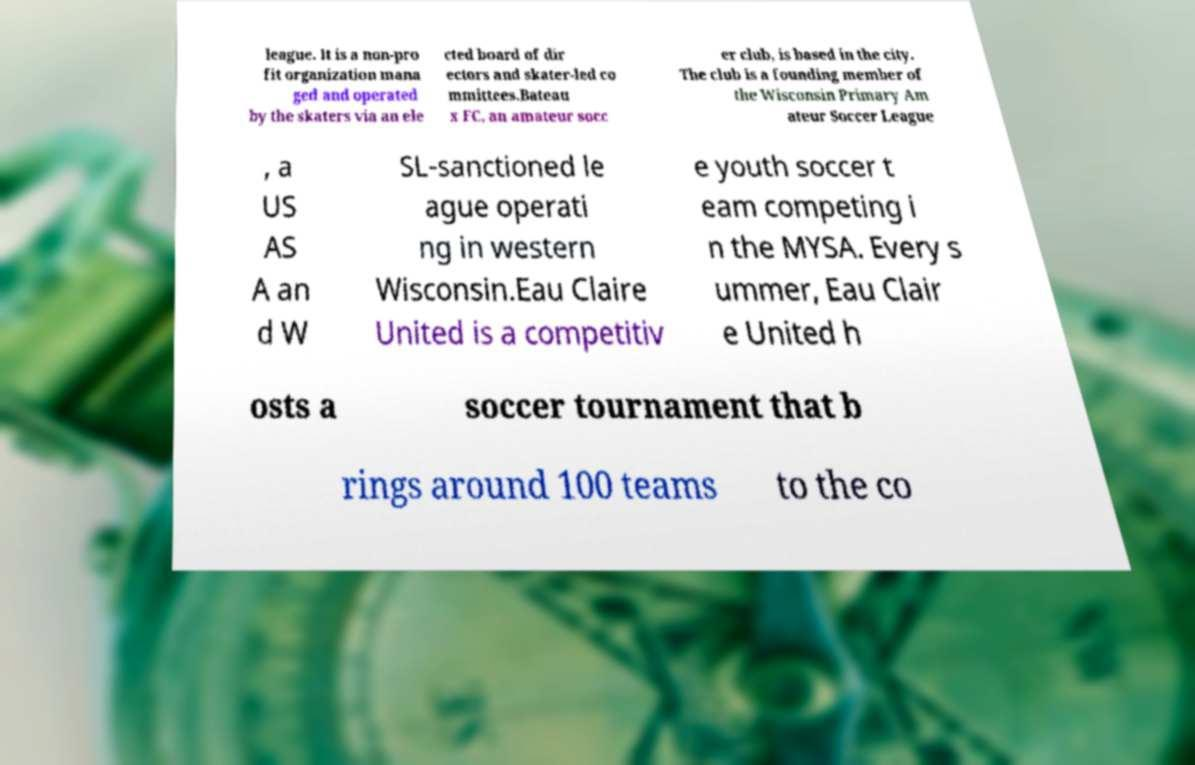Can you accurately transcribe the text from the provided image for me? league. It is a non-pro fit organization mana ged and operated by the skaters via an ele cted board of dir ectors and skater-led co mmittees.Bateau x FC, an amateur socc er club, is based in the city. The club is a founding member of the Wisconsin Primary Am ateur Soccer League , a US AS A an d W SL-sanctioned le ague operati ng in western Wisconsin.Eau Claire United is a competitiv e youth soccer t eam competing i n the MYSA. Every s ummer, Eau Clair e United h osts a soccer tournament that b rings around 100 teams to the co 